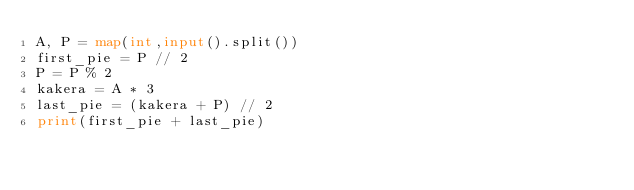<code> <loc_0><loc_0><loc_500><loc_500><_Python_>A, P = map(int,input().split())
first_pie = P // 2
P = P % 2
kakera = A * 3
last_pie = (kakera + P) // 2
print(first_pie + last_pie)</code> 